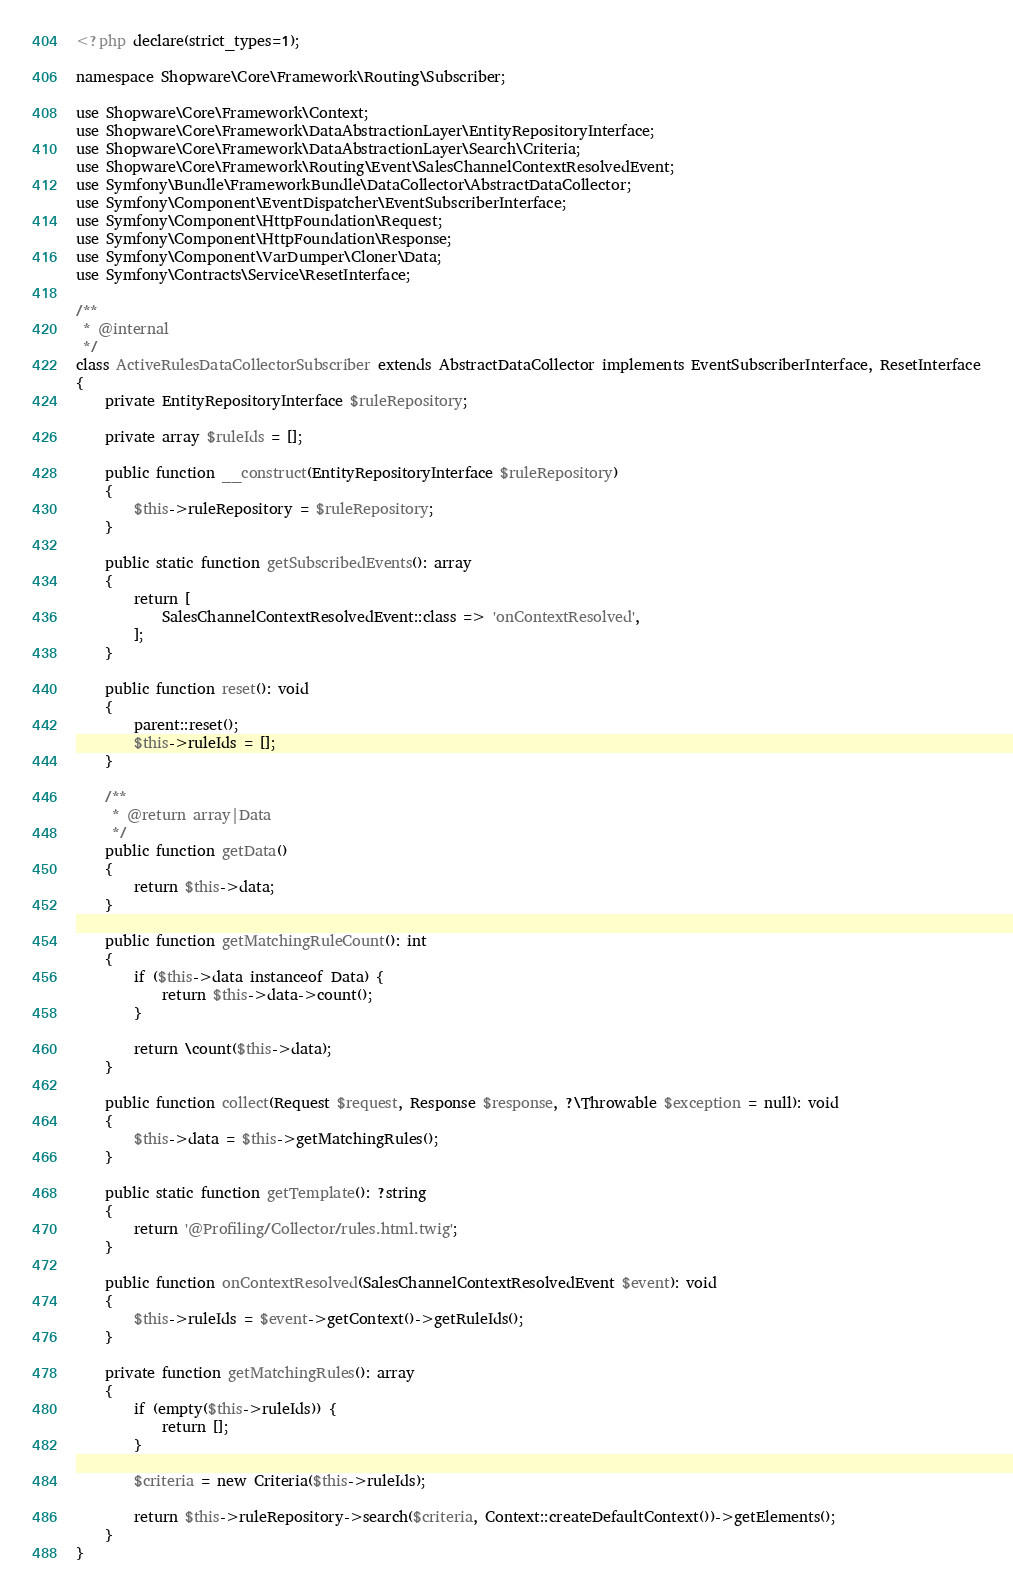<code> <loc_0><loc_0><loc_500><loc_500><_PHP_><?php declare(strict_types=1);

namespace Shopware\Core\Framework\Routing\Subscriber;

use Shopware\Core\Framework\Context;
use Shopware\Core\Framework\DataAbstractionLayer\EntityRepositoryInterface;
use Shopware\Core\Framework\DataAbstractionLayer\Search\Criteria;
use Shopware\Core\Framework\Routing\Event\SalesChannelContextResolvedEvent;
use Symfony\Bundle\FrameworkBundle\DataCollector\AbstractDataCollector;
use Symfony\Component\EventDispatcher\EventSubscriberInterface;
use Symfony\Component\HttpFoundation\Request;
use Symfony\Component\HttpFoundation\Response;
use Symfony\Component\VarDumper\Cloner\Data;
use Symfony\Contracts\Service\ResetInterface;

/**
 * @internal
 */
class ActiveRulesDataCollectorSubscriber extends AbstractDataCollector implements EventSubscriberInterface, ResetInterface
{
    private EntityRepositoryInterface $ruleRepository;

    private array $ruleIds = [];

    public function __construct(EntityRepositoryInterface $ruleRepository)
    {
        $this->ruleRepository = $ruleRepository;
    }

    public static function getSubscribedEvents(): array
    {
        return [
            SalesChannelContextResolvedEvent::class => 'onContextResolved',
        ];
    }

    public function reset(): void
    {
        parent::reset();
        $this->ruleIds = [];
    }

    /**
     * @return array|Data
     */
    public function getData()
    {
        return $this->data;
    }

    public function getMatchingRuleCount(): int
    {
        if ($this->data instanceof Data) {
            return $this->data->count();
        }

        return \count($this->data);
    }

    public function collect(Request $request, Response $response, ?\Throwable $exception = null): void
    {
        $this->data = $this->getMatchingRules();
    }

    public static function getTemplate(): ?string
    {
        return '@Profiling/Collector/rules.html.twig';
    }

    public function onContextResolved(SalesChannelContextResolvedEvent $event): void
    {
        $this->ruleIds = $event->getContext()->getRuleIds();
    }

    private function getMatchingRules(): array
    {
        if (empty($this->ruleIds)) {
            return [];
        }

        $criteria = new Criteria($this->ruleIds);

        return $this->ruleRepository->search($criteria, Context::createDefaultContext())->getElements();
    }
}
</code> 